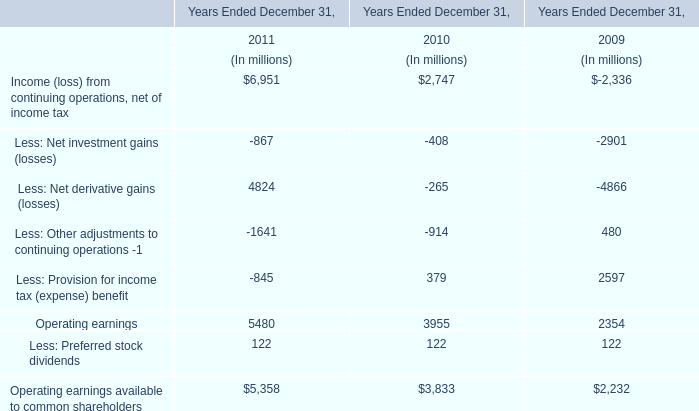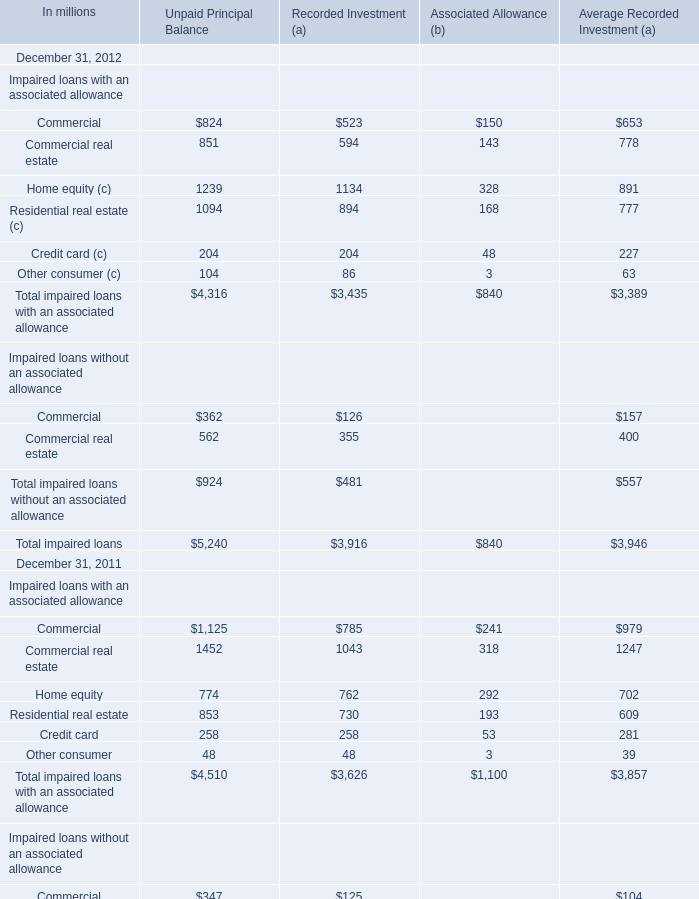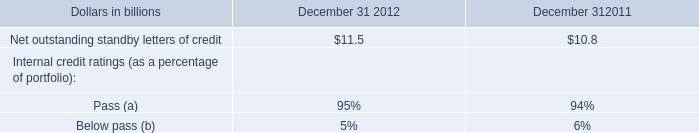How many elements show negative value in 2012 for Unpaid Principal Balance? 
Answer: 0. 